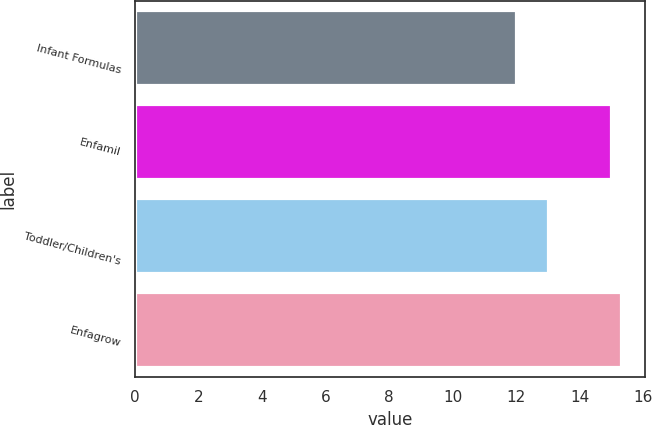Convert chart to OTSL. <chart><loc_0><loc_0><loc_500><loc_500><bar_chart><fcel>Infant Formulas<fcel>Enfamil<fcel>Toddler/Children's<fcel>Enfagrow<nl><fcel>12<fcel>15<fcel>13<fcel>15.3<nl></chart> 